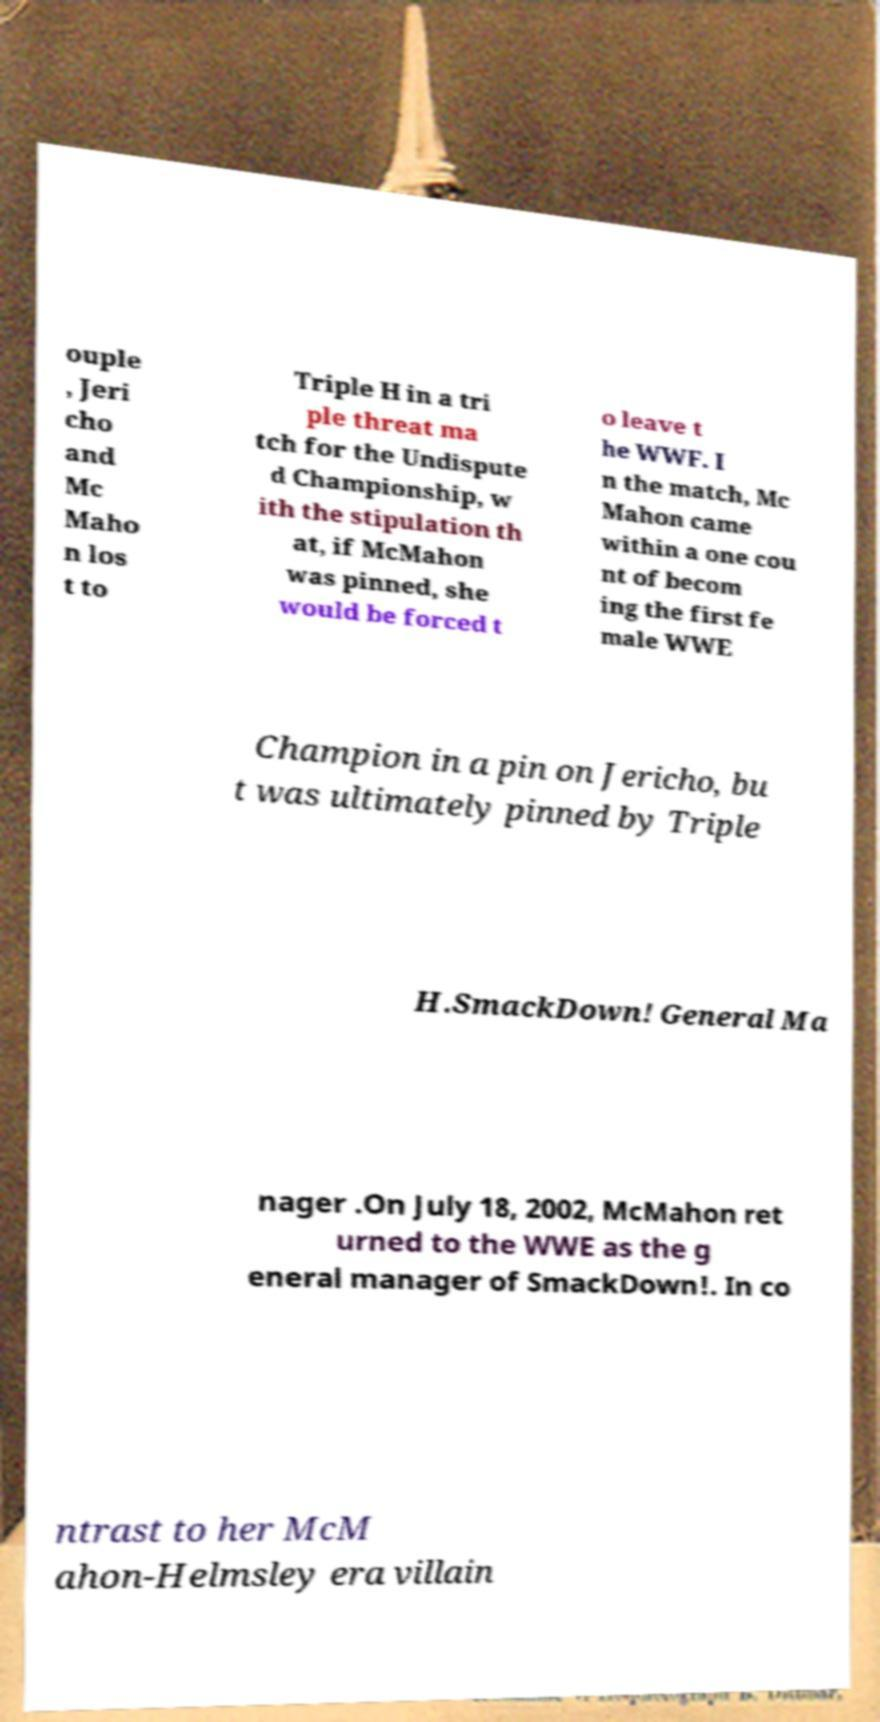What messages or text are displayed in this image? I need them in a readable, typed format. ouple , Jeri cho and Mc Maho n los t to Triple H in a tri ple threat ma tch for the Undispute d Championship, w ith the stipulation th at, if McMahon was pinned, she would be forced t o leave t he WWF. I n the match, Mc Mahon came within a one cou nt of becom ing the first fe male WWE Champion in a pin on Jericho, bu t was ultimately pinned by Triple H.SmackDown! General Ma nager .On July 18, 2002, McMahon ret urned to the WWE as the g eneral manager of SmackDown!. In co ntrast to her McM ahon-Helmsley era villain 